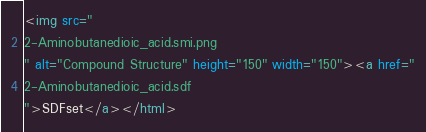<code> <loc_0><loc_0><loc_500><loc_500><_HTML_><img src="
2-Aminobutanedioic_acid.smi.png
" alt="Compound Structure" height="150" width="150"><a href="
2-Aminobutanedioic_acid.sdf
">SDFset</a></html>

</code> 